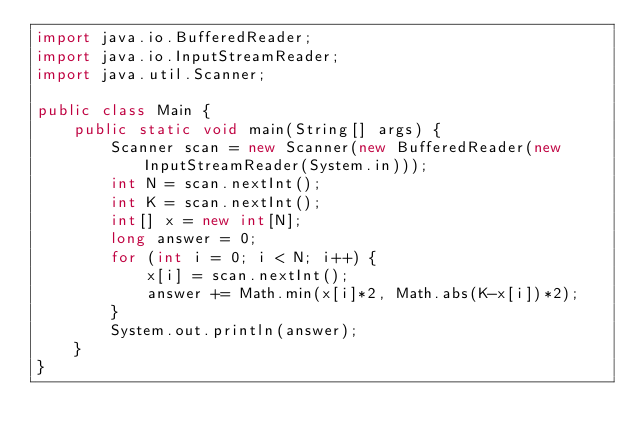Convert code to text. <code><loc_0><loc_0><loc_500><loc_500><_Java_>import java.io.BufferedReader;
import java.io.InputStreamReader;
import java.util.Scanner;

public class Main {
    public static void main(String[] args) {
        Scanner scan = new Scanner(new BufferedReader(new InputStreamReader(System.in)));
        int N = scan.nextInt();
        int K = scan.nextInt();
        int[] x = new int[N];
        long answer = 0;
        for (int i = 0; i < N; i++) {
            x[i] = scan.nextInt();
            answer += Math.min(x[i]*2, Math.abs(K-x[i])*2);
        }
        System.out.println(answer);
    }
}
</code> 